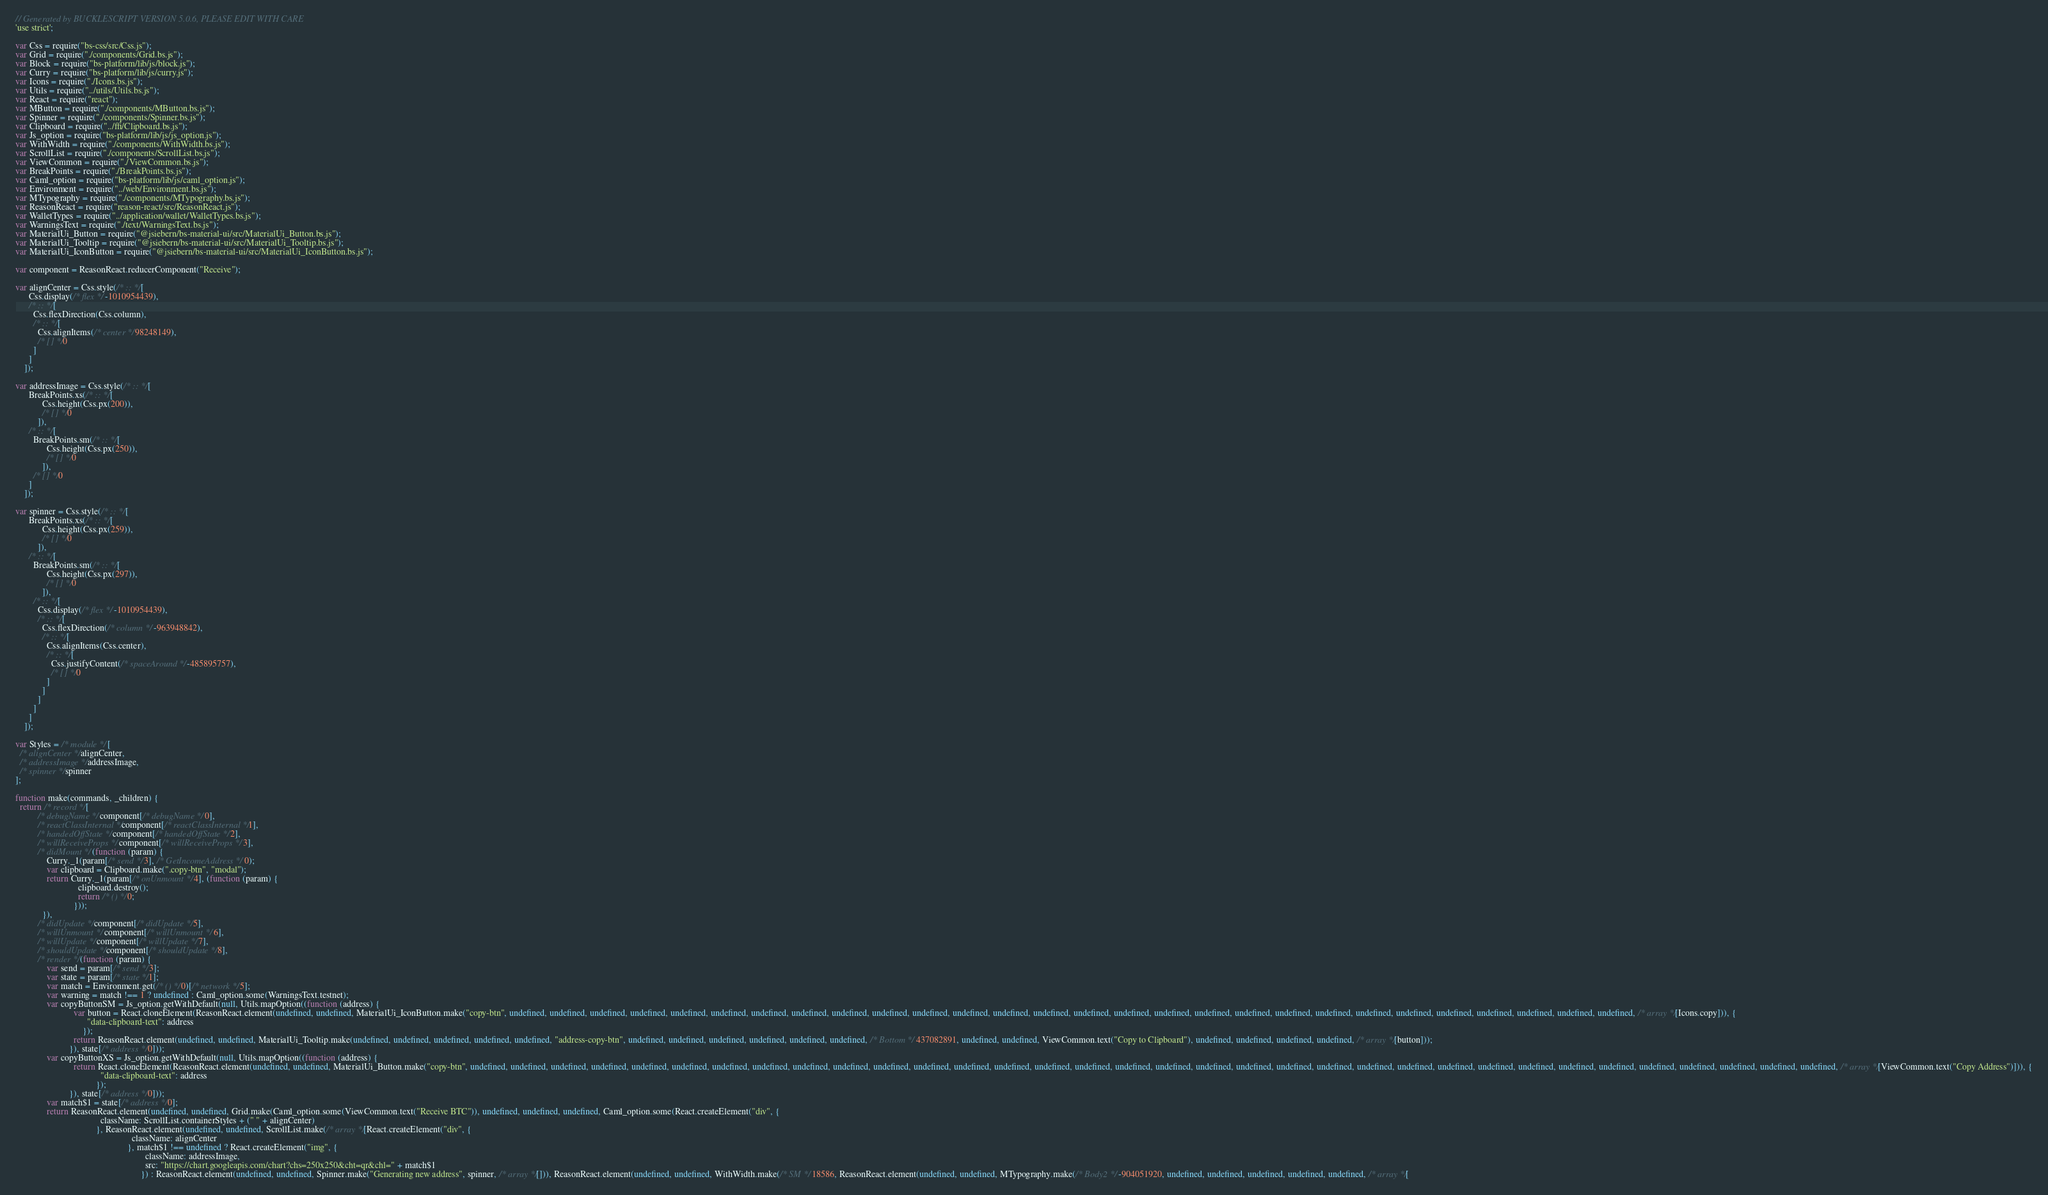<code> <loc_0><loc_0><loc_500><loc_500><_JavaScript_>// Generated by BUCKLESCRIPT VERSION 5.0.6, PLEASE EDIT WITH CARE
'use strict';

var Css = require("bs-css/src/Css.js");
var Grid = require("./components/Grid.bs.js");
var Block = require("bs-platform/lib/js/block.js");
var Curry = require("bs-platform/lib/js/curry.js");
var Icons = require("./Icons.bs.js");
var Utils = require("../utils/Utils.bs.js");
var React = require("react");
var MButton = require("./components/MButton.bs.js");
var Spinner = require("./components/Spinner.bs.js");
var Clipboard = require("../ffi/Clipboard.bs.js");
var Js_option = require("bs-platform/lib/js/js_option.js");
var WithWidth = require("./components/WithWidth.bs.js");
var ScrollList = require("./components/ScrollList.bs.js");
var ViewCommon = require("./ViewCommon.bs.js");
var BreakPoints = require("./BreakPoints.bs.js");
var Caml_option = require("bs-platform/lib/js/caml_option.js");
var Environment = require("../web/Environment.bs.js");
var MTypography = require("./components/MTypography.bs.js");
var ReasonReact = require("reason-react/src/ReasonReact.js");
var WalletTypes = require("../application/wallet/WalletTypes.bs.js");
var WarningsText = require("./text/WarningsText.bs.js");
var MaterialUi_Button = require("@jsiebern/bs-material-ui/src/MaterialUi_Button.bs.js");
var MaterialUi_Tooltip = require("@jsiebern/bs-material-ui/src/MaterialUi_Tooltip.bs.js");
var MaterialUi_IconButton = require("@jsiebern/bs-material-ui/src/MaterialUi_IconButton.bs.js");

var component = ReasonReact.reducerComponent("Receive");

var alignCenter = Css.style(/* :: */[
      Css.display(/* flex */-1010954439),
      /* :: */[
        Css.flexDirection(Css.column),
        /* :: */[
          Css.alignItems(/* center */98248149),
          /* [] */0
        ]
      ]
    ]);

var addressImage = Css.style(/* :: */[
      BreakPoints.xs(/* :: */[
            Css.height(Css.px(200)),
            /* [] */0
          ]),
      /* :: */[
        BreakPoints.sm(/* :: */[
              Css.height(Css.px(250)),
              /* [] */0
            ]),
        /* [] */0
      ]
    ]);

var spinner = Css.style(/* :: */[
      BreakPoints.xs(/* :: */[
            Css.height(Css.px(259)),
            /* [] */0
          ]),
      /* :: */[
        BreakPoints.sm(/* :: */[
              Css.height(Css.px(297)),
              /* [] */0
            ]),
        /* :: */[
          Css.display(/* flex */-1010954439),
          /* :: */[
            Css.flexDirection(/* column */-963948842),
            /* :: */[
              Css.alignItems(Css.center),
              /* :: */[
                Css.justifyContent(/* spaceAround */-485895757),
                /* [] */0
              ]
            ]
          ]
        ]
      ]
    ]);

var Styles = /* module */[
  /* alignCenter */alignCenter,
  /* addressImage */addressImage,
  /* spinner */spinner
];

function make(commands, _children) {
  return /* record */[
          /* debugName */component[/* debugName */0],
          /* reactClassInternal */component[/* reactClassInternal */1],
          /* handedOffState */component[/* handedOffState */2],
          /* willReceiveProps */component[/* willReceiveProps */3],
          /* didMount */(function (param) {
              Curry._1(param[/* send */3], /* GetIncomeAddress */0);
              var clipboard = Clipboard.make(".copy-btn", "modal");
              return Curry._1(param[/* onUnmount */4], (function (param) {
                            clipboard.destroy();
                            return /* () */0;
                          }));
            }),
          /* didUpdate */component[/* didUpdate */5],
          /* willUnmount */component[/* willUnmount */6],
          /* willUpdate */component[/* willUpdate */7],
          /* shouldUpdate */component[/* shouldUpdate */8],
          /* render */(function (param) {
              var send = param[/* send */3];
              var state = param[/* state */1];
              var match = Environment.get(/* () */0)[/* network */5];
              var warning = match !== 1 ? undefined : Caml_option.some(WarningsText.testnet);
              var copyButtonSM = Js_option.getWithDefault(null, Utils.mapOption((function (address) {
                          var button = React.cloneElement(ReasonReact.element(undefined, undefined, MaterialUi_IconButton.make("copy-btn", undefined, undefined, undefined, undefined, undefined, undefined, undefined, undefined, undefined, undefined, undefined, undefined, undefined, undefined, undefined, undefined, undefined, undefined, undefined, undefined, undefined, undefined, undefined, undefined, undefined, undefined, undefined, undefined, /* array */[Icons.copy])), {
                                "data-clipboard-text": address
                              });
                          return ReasonReact.element(undefined, undefined, MaterialUi_Tooltip.make(undefined, undefined, undefined, undefined, undefined, "address-copy-btn", undefined, undefined, undefined, undefined, undefined, undefined, /* Bottom */437082891, undefined, undefined, ViewCommon.text("Copy to Clipboard"), undefined, undefined, undefined, undefined, /* array */[button]));
                        }), state[/* address */0]));
              var copyButtonXS = Js_option.getWithDefault(null, Utils.mapOption((function (address) {
                          return React.cloneElement(ReasonReact.element(undefined, undefined, MaterialUi_Button.make("copy-btn", undefined, undefined, undefined, undefined, undefined, undefined, undefined, undefined, undefined, undefined, undefined, undefined, undefined, undefined, undefined, undefined, undefined, undefined, undefined, undefined, undefined, undefined, undefined, undefined, undefined, undefined, undefined, undefined, undefined, undefined, undefined, undefined, undefined, undefined, /* array */[ViewCommon.text("Copy Address")])), {
                                      "data-clipboard-text": address
                                    });
                        }), state[/* address */0]));
              var match$1 = state[/* address */0];
              return ReasonReact.element(undefined, undefined, Grid.make(Caml_option.some(ViewCommon.text("Receive BTC")), undefined, undefined, undefined, Caml_option.some(React.createElement("div", {
                                      className: ScrollList.containerStyles + (" " + alignCenter)
                                    }, ReasonReact.element(undefined, undefined, ScrollList.make(/* array */[React.createElement("div", {
                                                    className: alignCenter
                                                  }, match$1 !== undefined ? React.createElement("img", {
                                                          className: addressImage,
                                                          src: "https://chart.googleapis.com/chart?chs=250x250&cht=qr&chl=" + match$1
                                                        }) : ReasonReact.element(undefined, undefined, Spinner.make("Generating new address", spinner, /* array */[])), ReasonReact.element(undefined, undefined, WithWidth.make(/* SM */18586, ReasonReact.element(undefined, undefined, MTypography.make(/* Body2 */-904051920, undefined, undefined, undefined, undefined, undefined, /* array */[</code> 